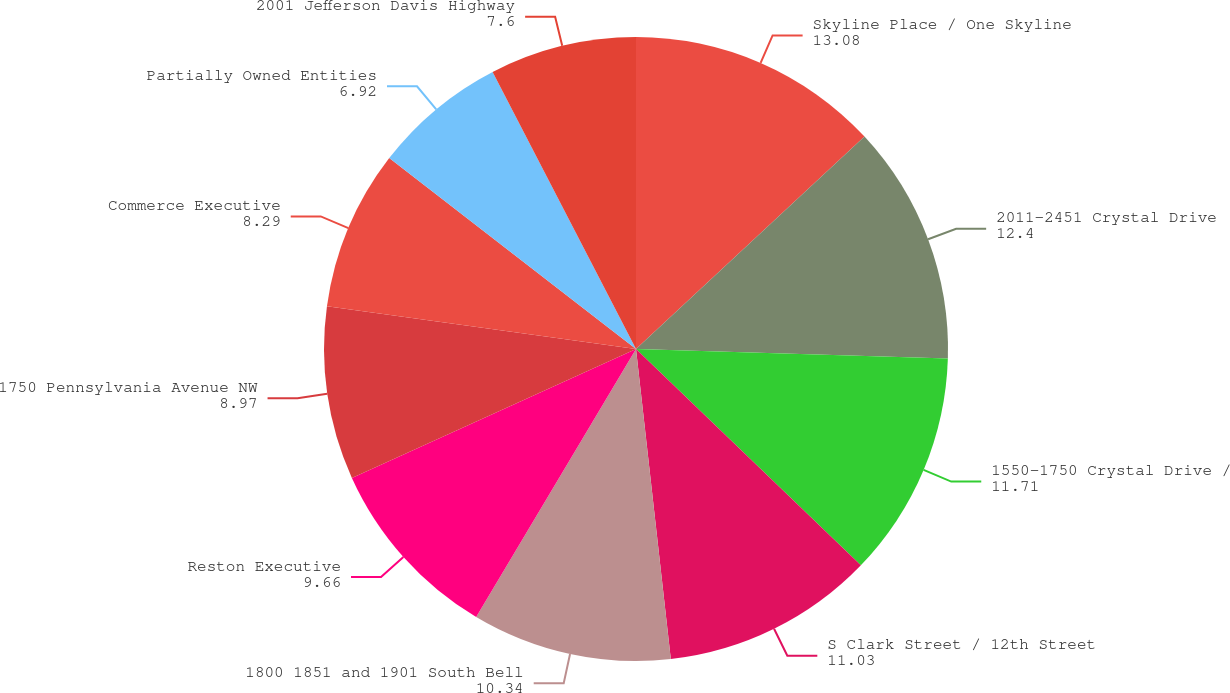Convert chart. <chart><loc_0><loc_0><loc_500><loc_500><pie_chart><fcel>Skyline Place / One Skyline<fcel>2011-2451 Crystal Drive<fcel>1550-1750 Crystal Drive /<fcel>S Clark Street / 12th Street<fcel>1800 1851 and 1901 South Bell<fcel>Reston Executive<fcel>1750 Pennsylvania Avenue NW<fcel>Commerce Executive<fcel>Partially Owned Entities<fcel>2001 Jefferson Davis Highway<nl><fcel>13.08%<fcel>12.4%<fcel>11.71%<fcel>11.03%<fcel>10.34%<fcel>9.66%<fcel>8.97%<fcel>8.29%<fcel>6.92%<fcel>7.6%<nl></chart> 